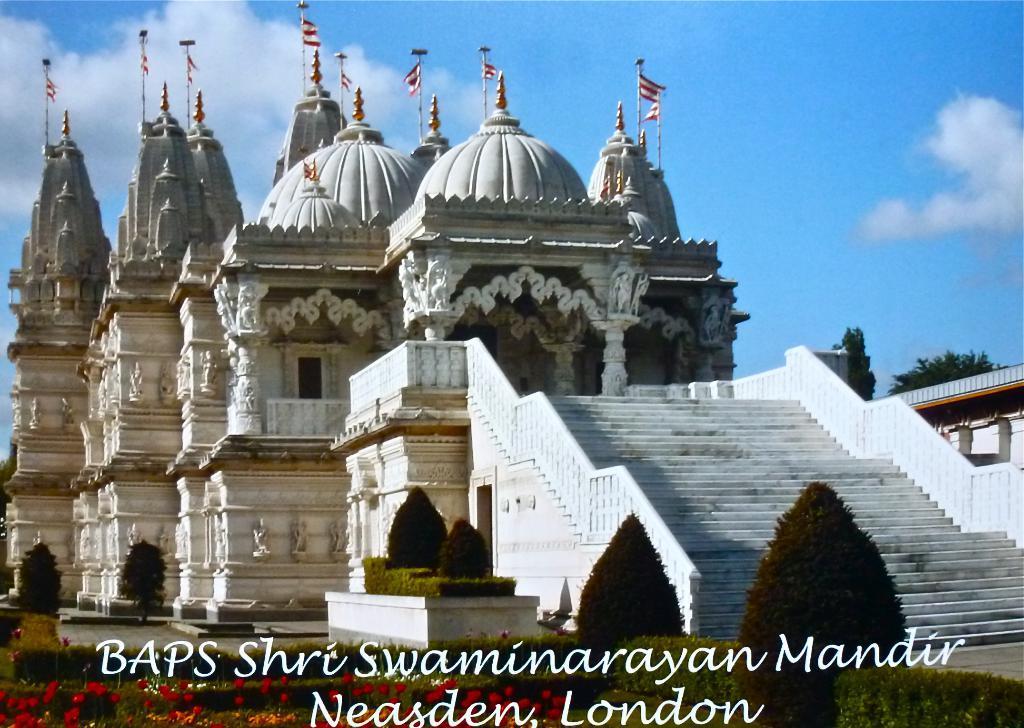Please provide a concise description of this image. In this image I can see plants and trees in green color, background I can see a building in white color, flags in white and red color, and the sky is in blue and white color. 